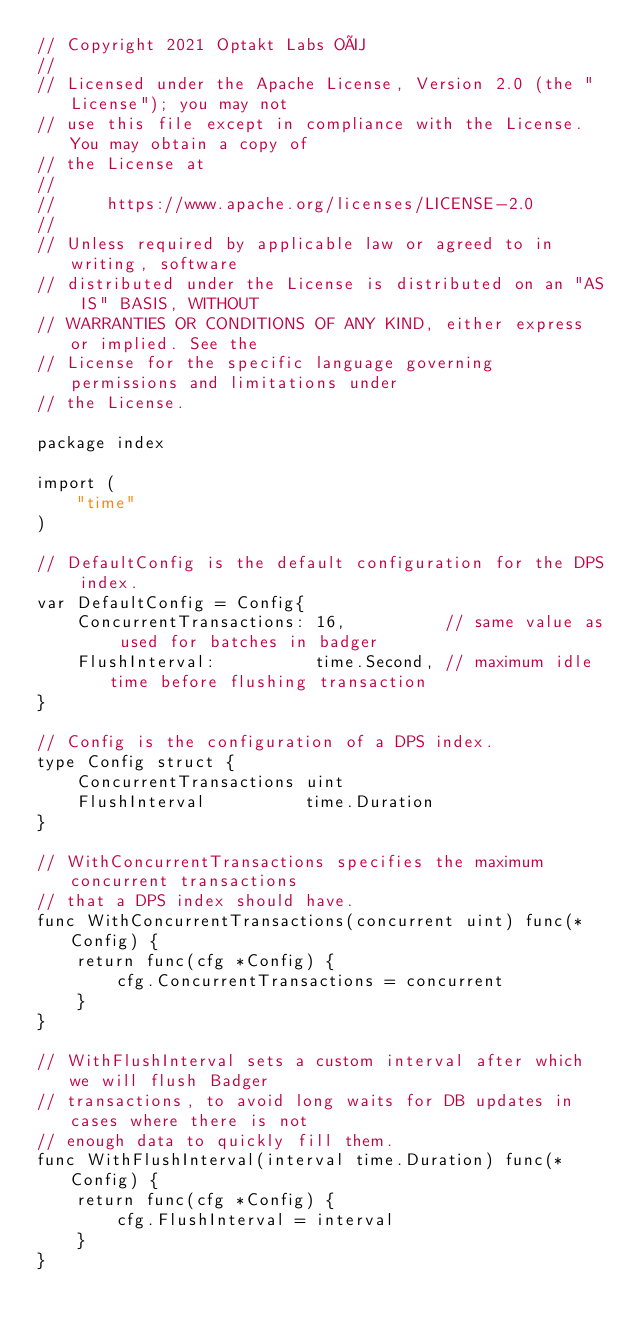<code> <loc_0><loc_0><loc_500><loc_500><_Go_>// Copyright 2021 Optakt Labs OÜ
//
// Licensed under the Apache License, Version 2.0 (the "License"); you may not
// use this file except in compliance with the License. You may obtain a copy of
// the License at
//
//     https://www.apache.org/licenses/LICENSE-2.0
//
// Unless required by applicable law or agreed to in writing, software
// distributed under the License is distributed on an "AS IS" BASIS, WITHOUT
// WARRANTIES OR CONDITIONS OF ANY KIND, either express or implied. See the
// License for the specific language governing permissions and limitations under
// the License.

package index

import (
	"time"
)

// DefaultConfig is the default configuration for the DPS index.
var DefaultConfig = Config{
	ConcurrentTransactions: 16,          // same value as used for batches in badger
	FlushInterval:          time.Second, // maximum idle time before flushing transaction
}

// Config is the configuration of a DPS index.
type Config struct {
	ConcurrentTransactions uint
	FlushInterval          time.Duration
}

// WithConcurrentTransactions specifies the maximum concurrent transactions
// that a DPS index should have.
func WithConcurrentTransactions(concurrent uint) func(*Config) {
	return func(cfg *Config) {
		cfg.ConcurrentTransactions = concurrent
	}
}

// WithFlushInterval sets a custom interval after which we will flush Badger
// transactions, to avoid long waits for DB updates in cases where there is not
// enough data to quickly fill them.
func WithFlushInterval(interval time.Duration) func(*Config) {
	return func(cfg *Config) {
		cfg.FlushInterval = interval
	}
}
</code> 